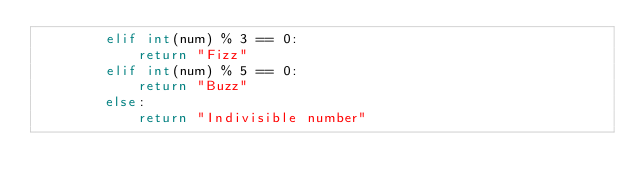Convert code to text. <code><loc_0><loc_0><loc_500><loc_500><_Python_>        elif int(num) % 3 == 0:
            return "Fizz"
        elif int(num) % 5 == 0:
            return "Buzz"
        else:
            return "Indivisible number"
</code> 